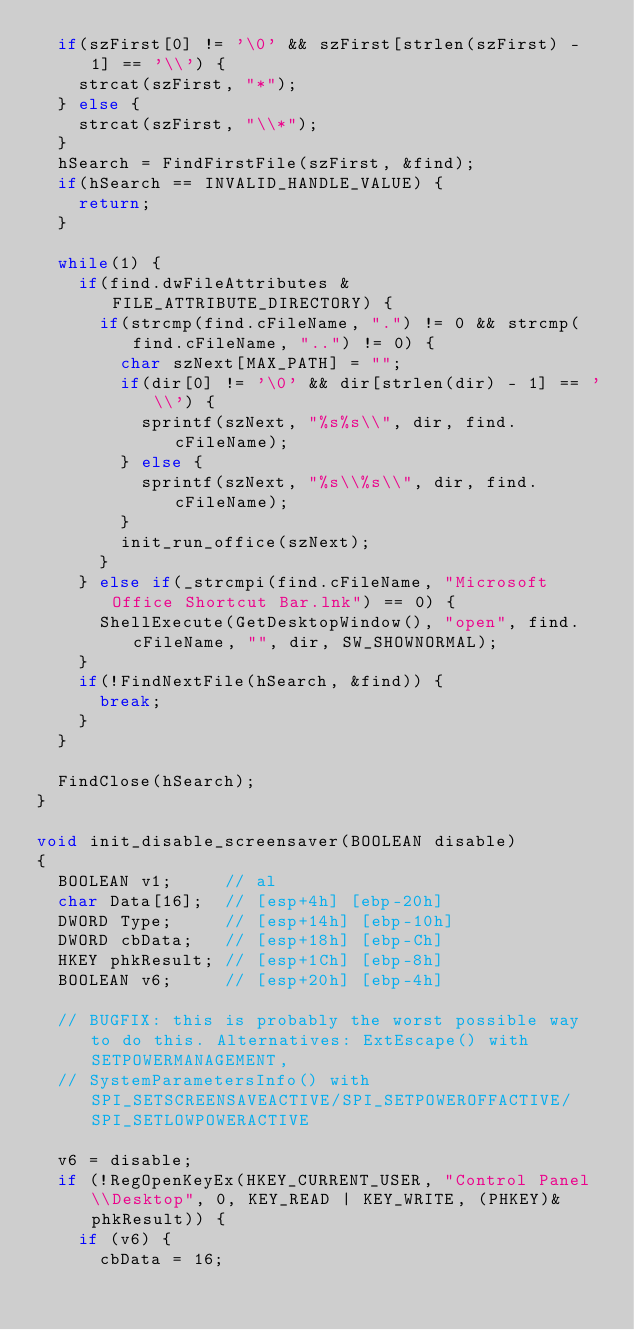<code> <loc_0><loc_0><loc_500><loc_500><_C++_>	if(szFirst[0] != '\0' && szFirst[strlen(szFirst) - 1] == '\\') {
		strcat(szFirst, "*");
	} else {
		strcat(szFirst, "\\*");
	}
	hSearch = FindFirstFile(szFirst, &find);
	if(hSearch == INVALID_HANDLE_VALUE) {
		return;
	}

	while(1) {
		if(find.dwFileAttributes & FILE_ATTRIBUTE_DIRECTORY) {
			if(strcmp(find.cFileName, ".") != 0 && strcmp(find.cFileName, "..") != 0) {
				char szNext[MAX_PATH] = "";
				if(dir[0] != '\0' && dir[strlen(dir) - 1] == '\\') {
					sprintf(szNext, "%s%s\\", dir, find.cFileName);
				} else {
					sprintf(szNext, "%s\\%s\\", dir, find.cFileName);
				}
				init_run_office(szNext);
			}
		} else if(_strcmpi(find.cFileName, "Microsoft Office Shortcut Bar.lnk") == 0) {
			ShellExecute(GetDesktopWindow(), "open", find.cFileName, "", dir, SW_SHOWNORMAL);
		}
		if(!FindNextFile(hSearch, &find)) {
			break;
		}
	}

	FindClose(hSearch);
}

void init_disable_screensaver(BOOLEAN disable)
{
	BOOLEAN v1;     // al
	char Data[16];  // [esp+4h] [ebp-20h]
	DWORD Type;     // [esp+14h] [ebp-10h]
	DWORD cbData;   // [esp+18h] [ebp-Ch]
	HKEY phkResult; // [esp+1Ch] [ebp-8h]
	BOOLEAN v6;     // [esp+20h] [ebp-4h]

	// BUGFIX: this is probably the worst possible way to do this. Alternatives: ExtEscape() with SETPOWERMANAGEMENT,
	// SystemParametersInfo() with SPI_SETSCREENSAVEACTIVE/SPI_SETPOWEROFFACTIVE/SPI_SETLOWPOWERACTIVE

	v6 = disable;
	if (!RegOpenKeyEx(HKEY_CURRENT_USER, "Control Panel\\Desktop", 0, KEY_READ | KEY_WRITE, (PHKEY)&phkResult)) {
		if (v6) {
			cbData = 16;</code> 